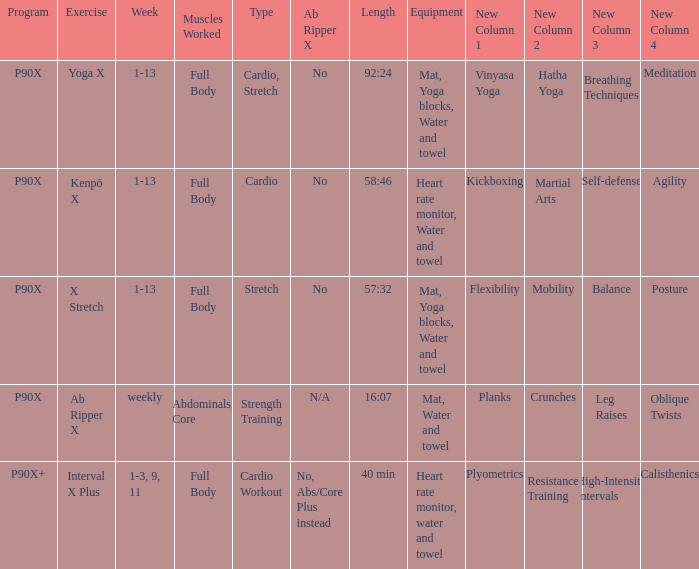Can you parse all the data within this table? {'header': ['Program', 'Exercise', 'Week', 'Muscles Worked', 'Type', 'Ab Ripper X', 'Length', 'Equipment', 'New Column 1', 'New Column 2', 'New Column 3', 'New Column 4'], 'rows': [['P90X', 'Yoga X', '1-13', 'Full Body', 'Cardio, Stretch', 'No', '92:24', 'Mat, Yoga blocks, Water and towel', 'Vinyasa Yoga', 'Hatha Yoga', 'Breathing Techniques', 'Meditation'], ['P90X', 'Kenpō X', '1-13', 'Full Body', 'Cardio', 'No', '58:46', 'Heart rate monitor, Water and towel', 'Kickboxing', 'Martial Arts', 'Self-defense', 'Agility'], ['P90X', 'X Stretch', '1-13', 'Full Body', 'Stretch', 'No', '57:32', 'Mat, Yoga blocks, Water and towel', 'Flexibility', 'Mobility', 'Balance', 'Posture'], ['P90X', 'Ab Ripper X', 'weekly', 'Abdominals, Core', 'Strength Training', 'N/A', '16:07', 'Mat, Water and towel', 'Planks', 'Crunches', 'Leg Raises', 'Oblique Twists'], ['P90X+', 'Interval X Plus', '1-3, 9, 11', 'Full Body', 'Cardio Workout', 'No, Abs/Core Plus instead', '40 min', 'Heart rate monitor, water and towel', 'Plyometrics', 'Resistance Training', 'High-Intensity Intervals', 'Calisthenics']]} What is the ab ripper x when exercise is x stretch? No. 